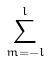Convert formula to latex. <formula><loc_0><loc_0><loc_500><loc_500>\sum _ { m = - l } ^ { l }</formula> 